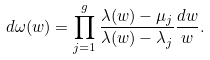Convert formula to latex. <formula><loc_0><loc_0><loc_500><loc_500>d \omega ( w ) = \prod _ { j = 1 } ^ { g } \frac { \lambda ( w ) - \mu _ { j } } { \lambda ( w ) - \lambda _ { j } } \frac { d w } { w } .</formula> 